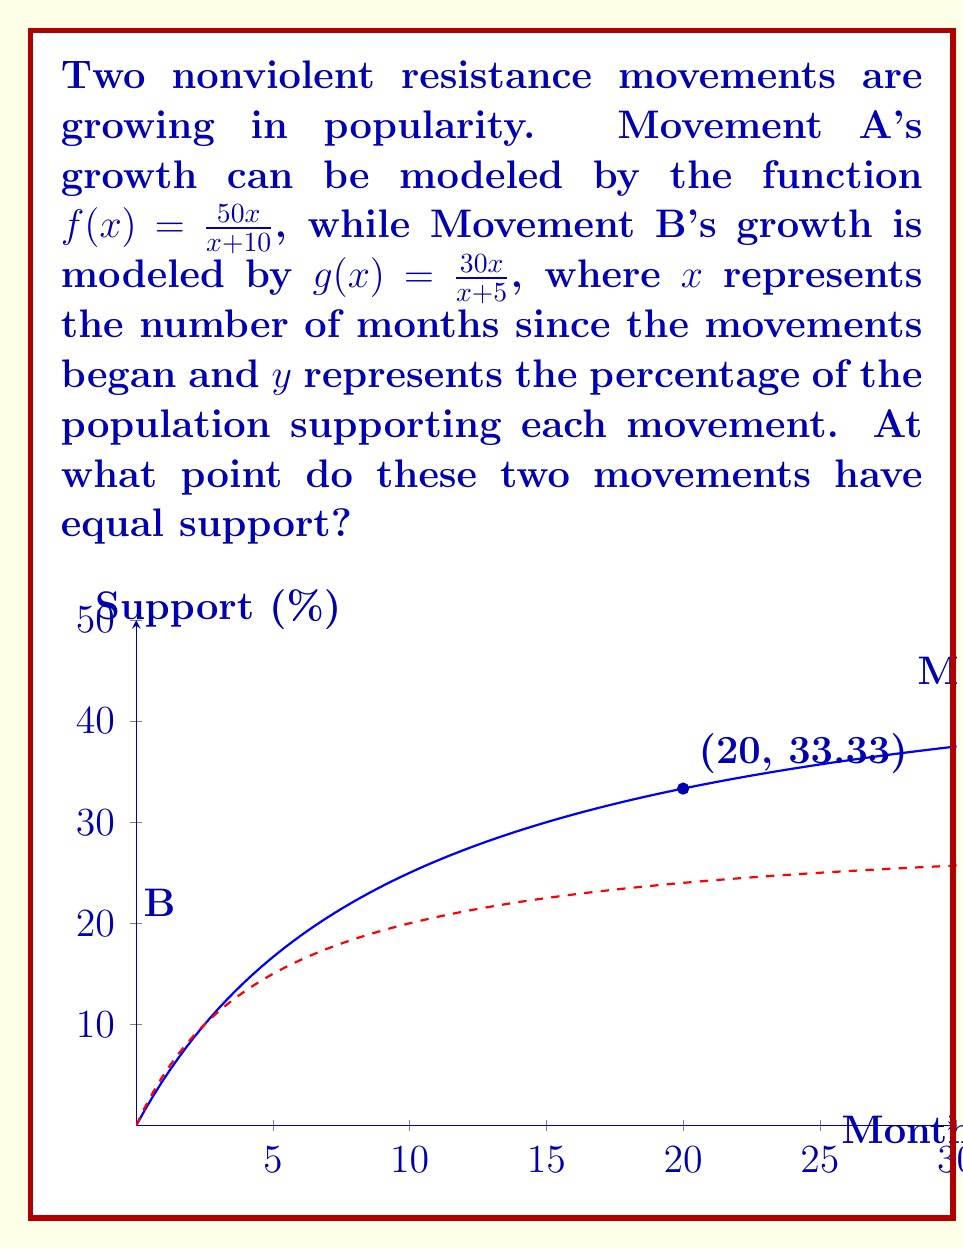Help me with this question. To find the intersection point, we need to solve the equation:

$$\frac{50x}{x+10} = \frac{30x}{x+5}$$

1) Cross-multiply to eliminate denominators:
   $50x(x+5) = 30x(x+10)$

2) Expand the brackets:
   $50x^2 + 250x = 30x^2 + 300x$

3) Subtract 30x^2 from both sides:
   $20x^2 + 250x = 300x$

4) Subtract 250x from both sides:
   $20x^2 = 50x$

5) Factor out x:
   $x(20x - 50) = 0$

6) Use the zero product property. Either $x = 0$ or $20x - 50 = 0$

7) Solve $20x - 50 = 0$:
   $20x = 50$
   $x = \frac{50}{20} = 2.5$

8) $x = 0$ is not a valid solution in this context, so $x = 2.5$ months is our solution.

9) To find the y-coordinate, substitute $x = 2.5$ into either function:
   $y = \frac{50(2.5)}{2.5+10} = \frac{125}{12.5} = 10$

Therefore, the intersection point is (2.5, 10).

However, since we're dealing with whole months, we should round to the nearest month:
$x = 3$ months

Recalculating y for x = 3:
$y = \frac{50(3)}{3+10} = \frac{150}{13} \approx 11.54$
Answer: (3, 11.54) 